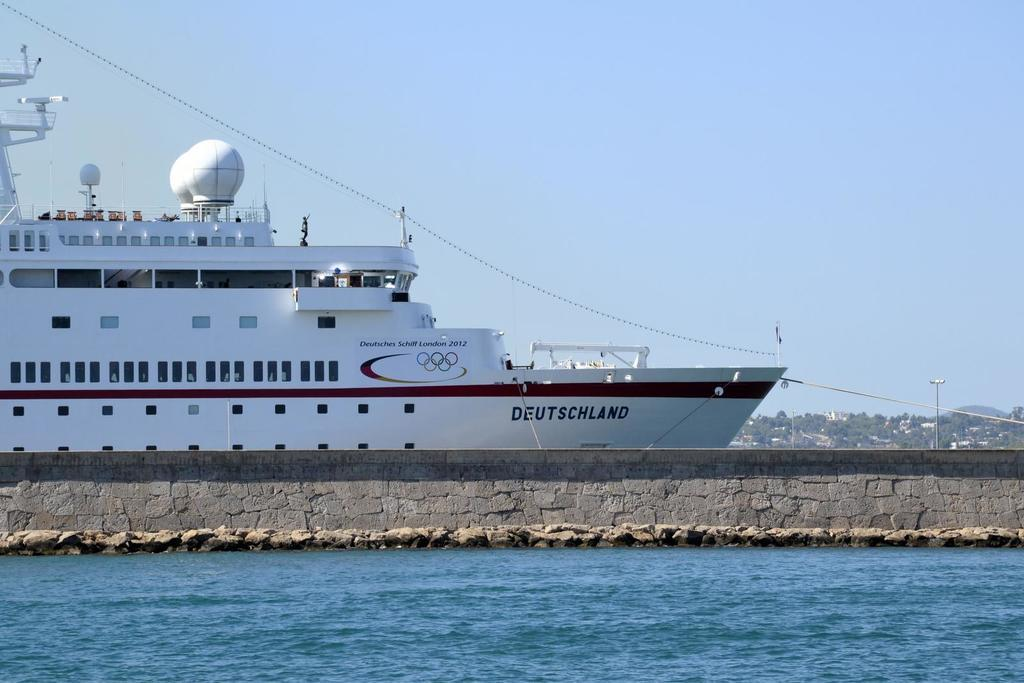What is present at the bottom of the image? There is water and a wall at the bottom of the image. What can be seen in the background of the image? There is a ship, hills, a pole, and the sky visible in the background of the image. What type of root can be seen growing from the ship in the image? There is no root growing from the ship in the image; it is a ship in the background of the image. How does the wound on the wall affect the water at the bottom of the image? There is no wound on the wall in the image, and the water is not affected by any wound. 